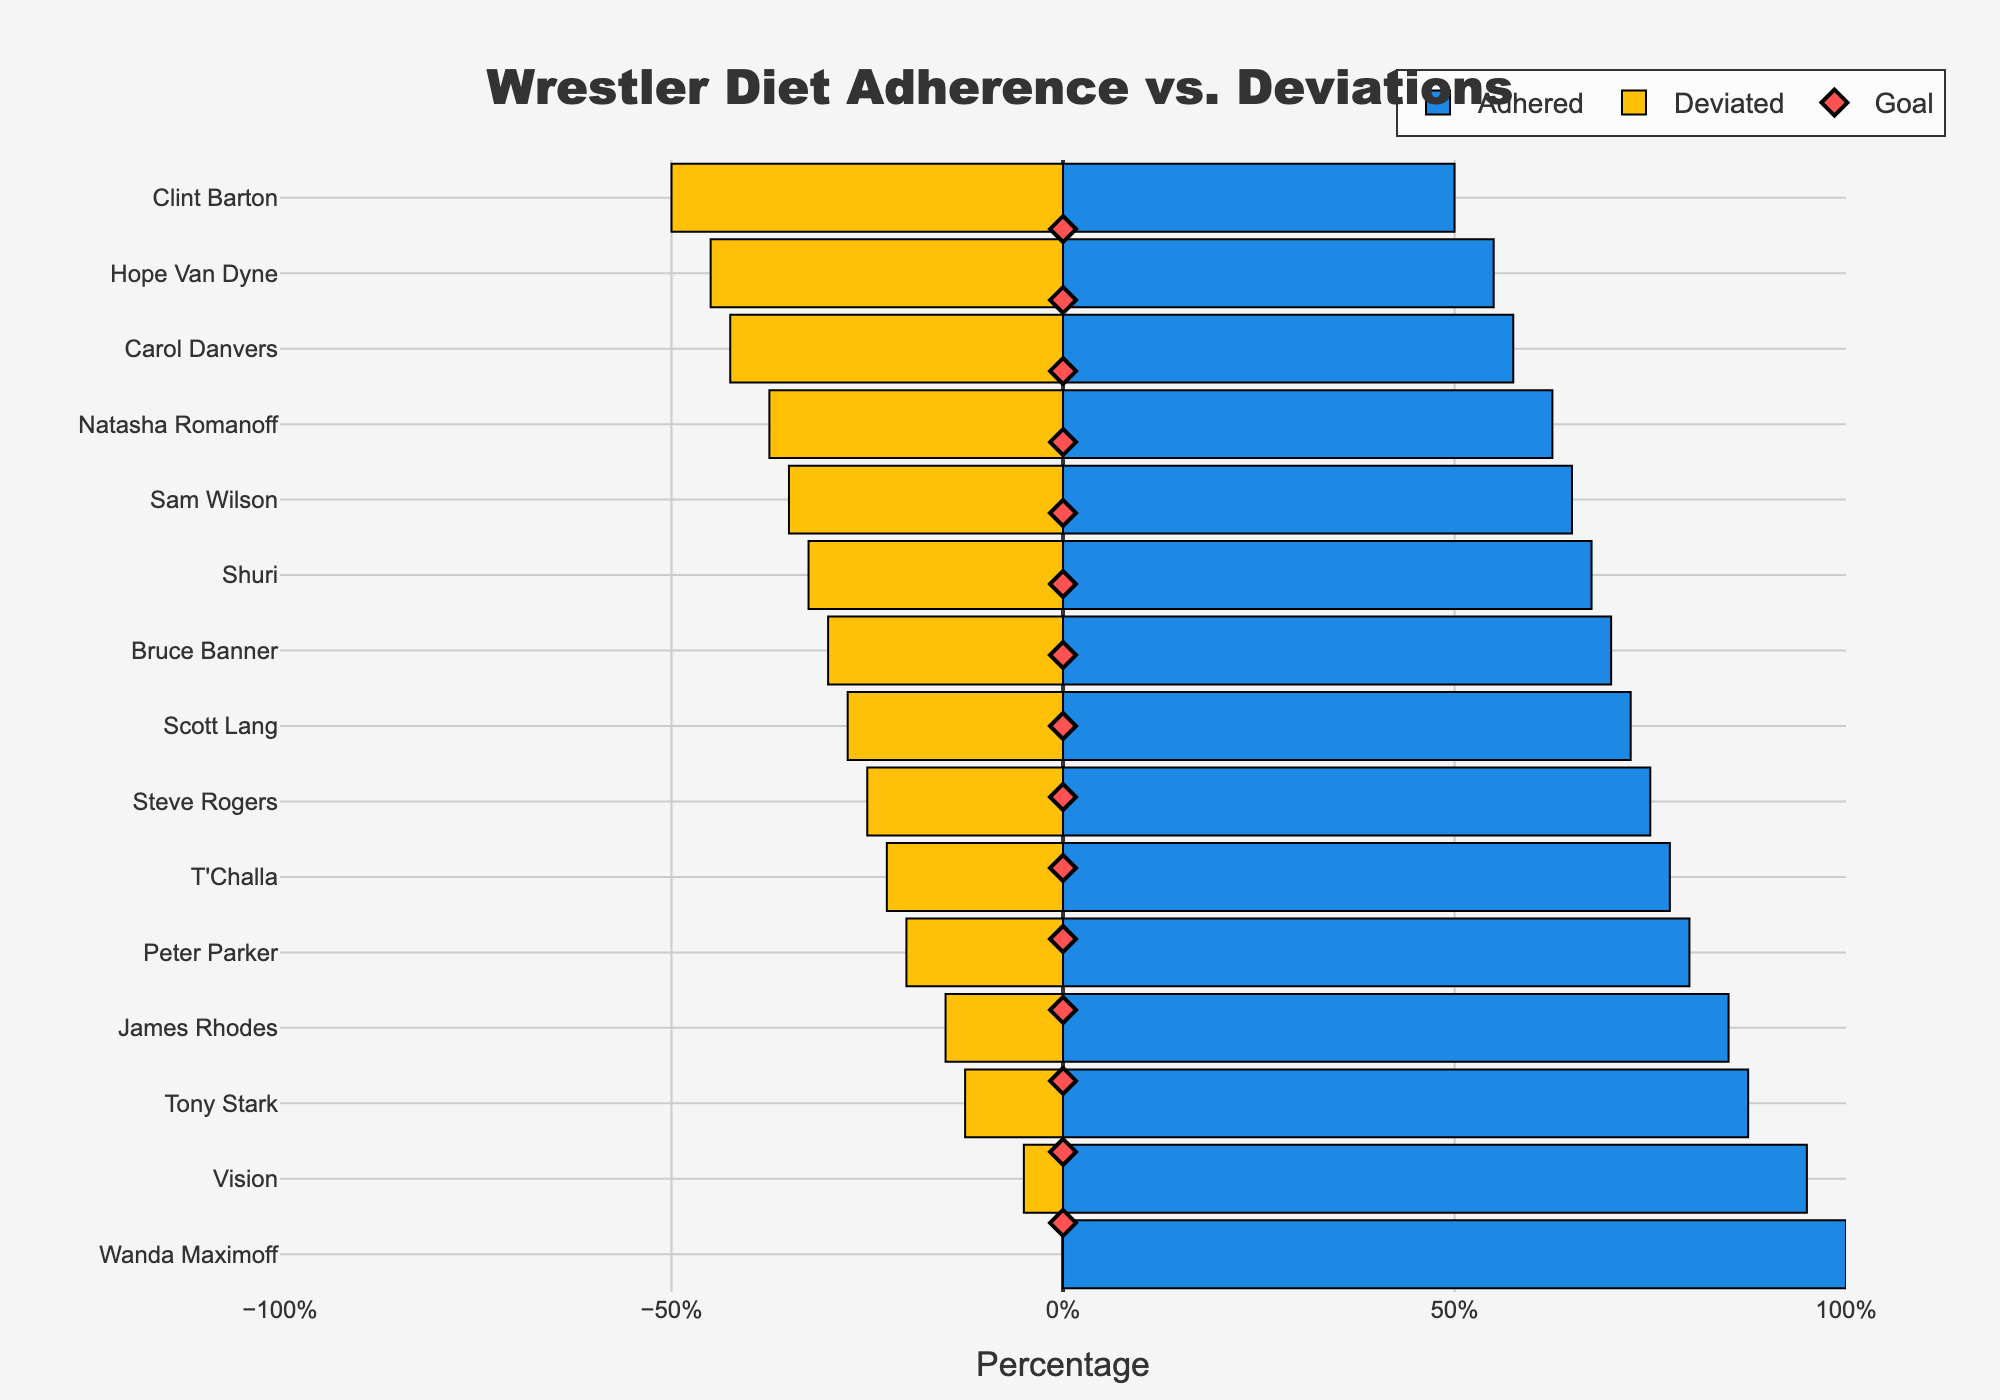Who has the highest adherence percentage? The figure displays the adherence percentage as the length of the blue bars. Wanda Maximoff has the longest blue bar, indicating the highest adherence percentage.
Answer: Wanda Maximoff Which wrestler has the lowest deviation percentage? The deviation percentage is represented by the length of the yellow bars. Wanda Maximoff has no yellow bar, indicating a deviation percentage of 0%.
Answer: Wanda Maximoff What is the sum of adherence percentages for Tony Stark and Vision? From the figure, Tony Stark's adherence percentage is represented by the length of his blue bar, which is 87.5%. Vision's adherence percentage is also shown as a blue bar, which is 95%. Adding them together: 87.5% + 95% = 182.5%.
Answer: 182.5% Who among the wrestlers with a goal of "Weight Maintenance" has the highest adherence percentage? For wrestlers with "Weight Maintenance" goals, compare the length of the blue bars. Sam Wilson has the longest blue bar in this category, indicating the highest adherence percentage.
Answer: Sam Wilson Compare the deviation percentages of Scott Lang and Bruce Banner. Who has a higher deviation percentage? Look at the lengths of the yellow bars for Scott Lang and Bruce Banner. Scott Lang's yellow bar represents a deviation percentage of 27.5% and Bruce Banner's yellow bar is 30%. Therefore, Bruce Banner has a higher deviation percentage.
Answer: Bruce Banner What is the average adherence percentage for wrestlers with a "Bulking" goal? The wrestlers with a "Bulking" goal are Tony Stark, Wanda Maximoff, James Rhodes, and Vision. Their adherence percentages are 87.5%, 100%, 85%, and 95% respectively. The average is calculated as (87.5 + 100 + 85 + 95) / 4 = 91.875%.
Answer: 91.875% How does Steve Rogers' adherence percentage compare to James Rhodes's adherence percentage? Steve Rogers' adherence percentage is represented by his blue bar, which is 75%. James Rhodes' adherence percentage is represented by his blue bar, which is 85%. James Rhodes' adherence percentage is higher than Steve Rogers'.
Answer: James Rhodes has a higher adherence percentage Which wrestler has a deviation percentage closest to 12%? Looking at the yellow bars, Bruce Banner's deviation percentage is 12%, making it the closest to 12%.
Answer: Bruce Banner Calculate the difference between the highest and lowest deviation percentages. The highest deviation percentage is Clint Barton's 50%. The lowest is Wanda Maximoff's 0%. The difference is 50% - 0% = 50%.
Answer: 50% Which wrestler with a "Weight Loss" goal has the lowest deviation percentage? For wrestlers with "Weight Loss" goals, compare the yellow bars. Peter Parker's yellow bar is the shortest, indicating a deviation percentage of 20%, which is the lowest in this category.
Answer: Peter Parker 